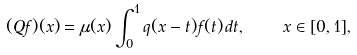<formula> <loc_0><loc_0><loc_500><loc_500>( Q f ) ( x ) = \mu ( x ) \int _ { 0 } ^ { 1 } q ( x - t ) f ( t ) \, d t , \quad x \in [ 0 , 1 ] ,</formula> 